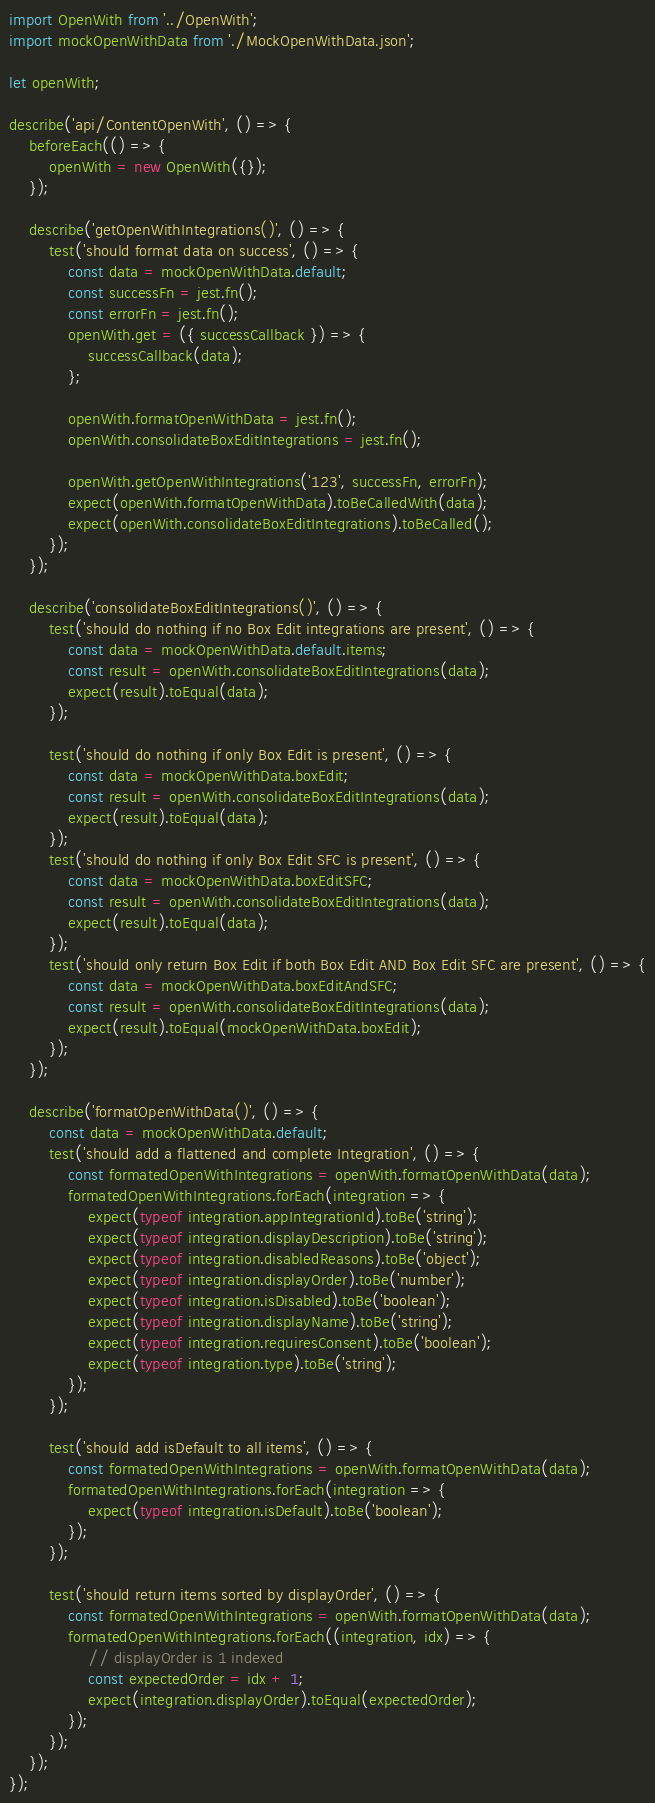Convert code to text. <code><loc_0><loc_0><loc_500><loc_500><_JavaScript_>import OpenWith from '../OpenWith';
import mockOpenWithData from './MockOpenWithData.json';

let openWith;

describe('api/ContentOpenWith', () => {
    beforeEach(() => {
        openWith = new OpenWith({});
    });

    describe('getOpenWithIntegrations()', () => {
        test('should format data on success', () => {
            const data = mockOpenWithData.default;
            const successFn = jest.fn();
            const errorFn = jest.fn();
            openWith.get = ({ successCallback }) => {
                successCallback(data);
            };

            openWith.formatOpenWithData = jest.fn();
            openWith.consolidateBoxEditIntegrations = jest.fn();

            openWith.getOpenWithIntegrations('123', successFn, errorFn);
            expect(openWith.formatOpenWithData).toBeCalledWith(data);
            expect(openWith.consolidateBoxEditIntegrations).toBeCalled();
        });
    });

    describe('consolidateBoxEditIntegrations()', () => {
        test('should do nothing if no Box Edit integrations are present', () => {
            const data = mockOpenWithData.default.items;
            const result = openWith.consolidateBoxEditIntegrations(data);
            expect(result).toEqual(data);
        });

        test('should do nothing if only Box Edit is present', () => {
            const data = mockOpenWithData.boxEdit;
            const result = openWith.consolidateBoxEditIntegrations(data);
            expect(result).toEqual(data);
        });
        test('should do nothing if only Box Edit SFC is present', () => {
            const data = mockOpenWithData.boxEditSFC;
            const result = openWith.consolidateBoxEditIntegrations(data);
            expect(result).toEqual(data);
        });
        test('should only return Box Edit if both Box Edit AND Box Edit SFC are present', () => {
            const data = mockOpenWithData.boxEditAndSFC;
            const result = openWith.consolidateBoxEditIntegrations(data);
            expect(result).toEqual(mockOpenWithData.boxEdit);
        });
    });

    describe('formatOpenWithData()', () => {
        const data = mockOpenWithData.default;
        test('should add a flattened and complete Integration', () => {
            const formatedOpenWithIntegrations = openWith.formatOpenWithData(data);
            formatedOpenWithIntegrations.forEach(integration => {
                expect(typeof integration.appIntegrationId).toBe('string');
                expect(typeof integration.displayDescription).toBe('string');
                expect(typeof integration.disabledReasons).toBe('object');
                expect(typeof integration.displayOrder).toBe('number');
                expect(typeof integration.isDisabled).toBe('boolean');
                expect(typeof integration.displayName).toBe('string');
                expect(typeof integration.requiresConsent).toBe('boolean');
                expect(typeof integration.type).toBe('string');
            });
        });

        test('should add isDefault to all items', () => {
            const formatedOpenWithIntegrations = openWith.formatOpenWithData(data);
            formatedOpenWithIntegrations.forEach(integration => {
                expect(typeof integration.isDefault).toBe('boolean');
            });
        });

        test('should return items sorted by displayOrder', () => {
            const formatedOpenWithIntegrations = openWith.formatOpenWithData(data);
            formatedOpenWithIntegrations.forEach((integration, idx) => {
                // displayOrder is 1 indexed
                const expectedOrder = idx + 1;
                expect(integration.displayOrder).toEqual(expectedOrder);
            });
        });
    });
});
</code> 